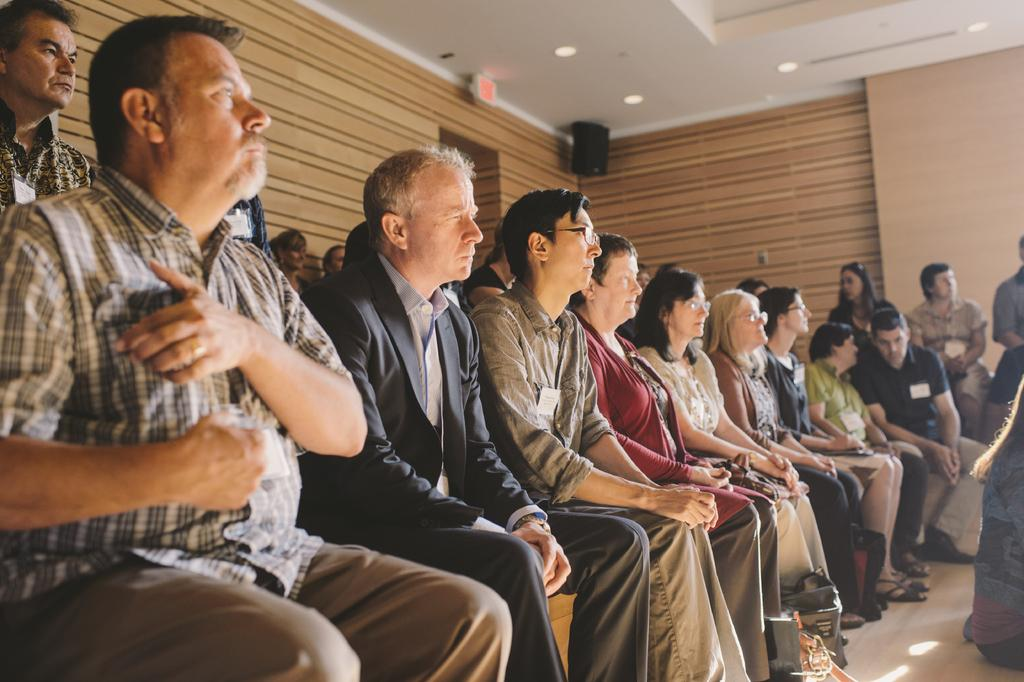What are the people in the image doing? There are many people sitting on chairs in the image. Can you describe the background of the image? There is a wall, persons, a speaker, and a door in the background of the image. How many people can be seen in the image? The number of people is not specified, but there are many people sitting on chairs. What might be the purpose of the speaker in the background? The speaker in the background might be used for amplifying sound during an event or gathering. Can you see any giants wearing crowns in the image? There are no giants or crowns present in the image. 